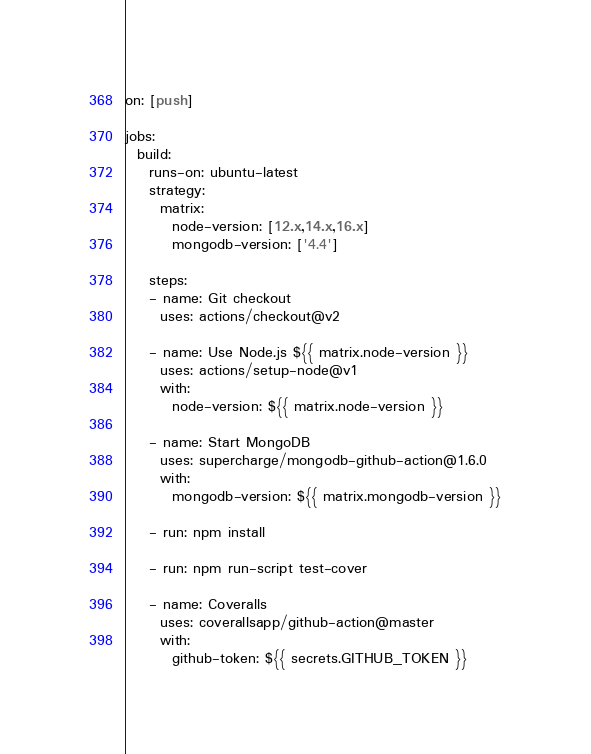<code> <loc_0><loc_0><loc_500><loc_500><_YAML_>on: [push]

jobs:
  build:
    runs-on: ubuntu-latest
    strategy:
      matrix:
        node-version: [12.x,14.x,16.x]
        mongodb-version: ['4.4']

    steps:
    - name: Git checkout
      uses: actions/checkout@v2

    - name: Use Node.js ${{ matrix.node-version }}
      uses: actions/setup-node@v1
      with:
        node-version: ${{ matrix.node-version }}

    - name: Start MongoDB
      uses: supercharge/mongodb-github-action@1.6.0
      with:
        mongodb-version: ${{ matrix.mongodb-version }}

    - run: npm install

    - run: npm run-script test-cover
    
    - name: Coveralls
      uses: coverallsapp/github-action@master
      with:
        github-token: ${{ secrets.GITHUB_TOKEN }}
</code> 